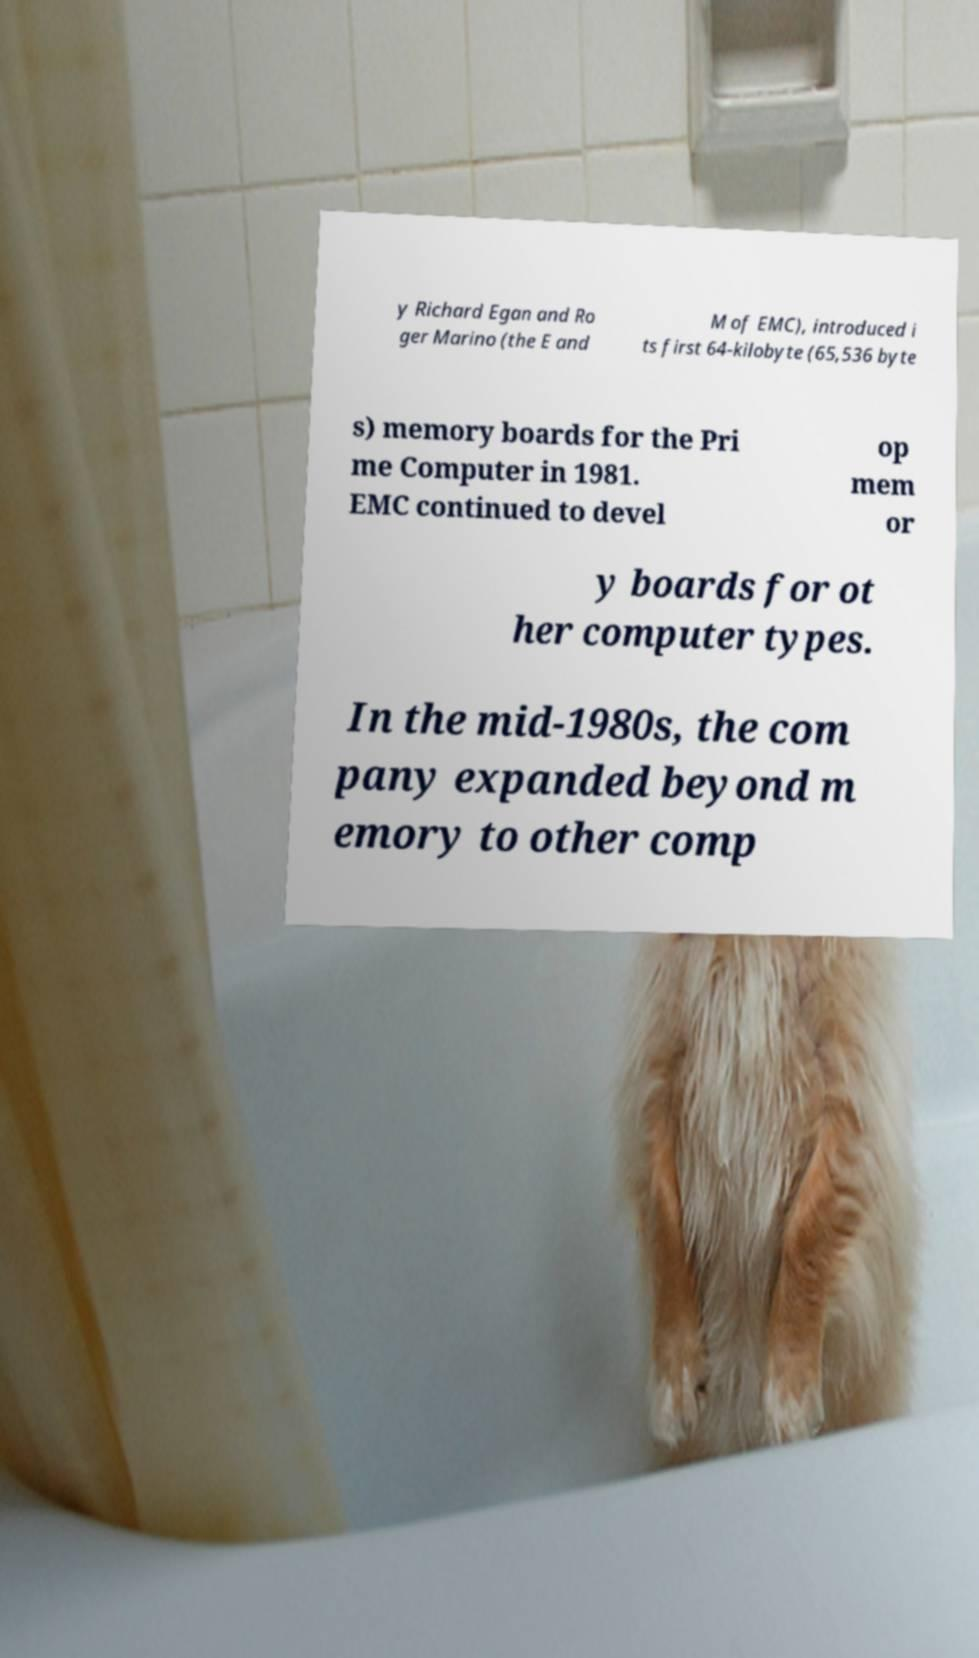Could you extract and type out the text from this image? y Richard Egan and Ro ger Marino (the E and M of EMC), introduced i ts first 64-kilobyte (65,536 byte s) memory boards for the Pri me Computer in 1981. EMC continued to devel op mem or y boards for ot her computer types. In the mid-1980s, the com pany expanded beyond m emory to other comp 